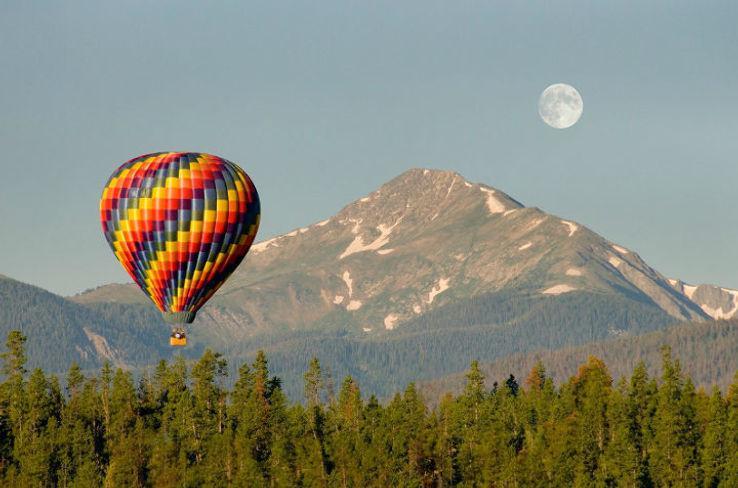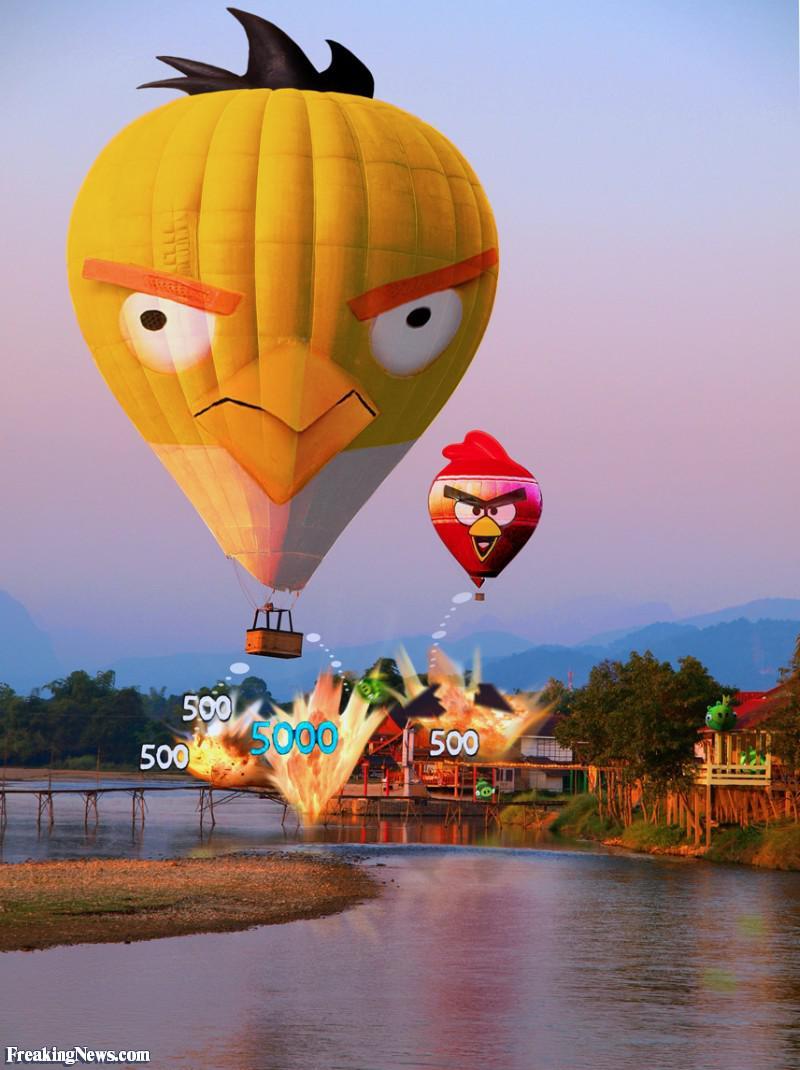The first image is the image on the left, the second image is the image on the right. Given the left and right images, does the statement "In one image, the balloon in the foreground has a face." hold true? Answer yes or no. Yes. The first image is the image on the left, the second image is the image on the right. For the images displayed, is the sentence "In one image, a face is designed on the side of a large yellow hot-air balloon." factually correct? Answer yes or no. Yes. 